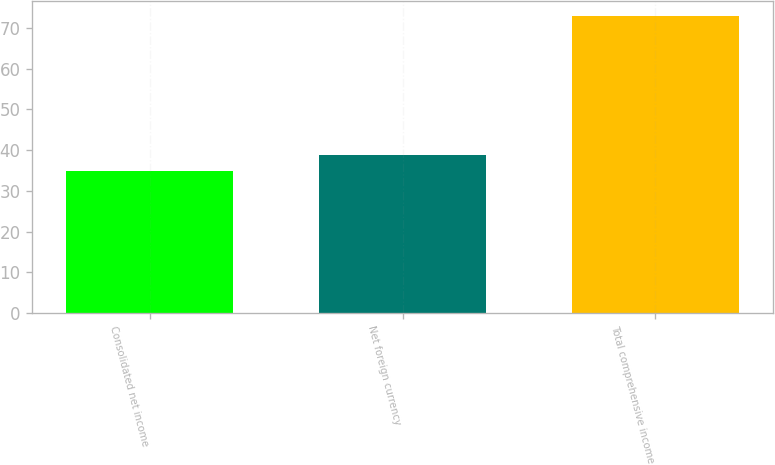<chart> <loc_0><loc_0><loc_500><loc_500><bar_chart><fcel>Consolidated net income<fcel>Net foreign currency<fcel>Total comprehensive income<nl><fcel>35<fcel>38.8<fcel>73<nl></chart> 